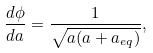Convert formula to latex. <formula><loc_0><loc_0><loc_500><loc_500>\frac { d \phi } { d a } = \frac { 1 } { \sqrt { a ( a + a _ { e q } ) } } ,</formula> 